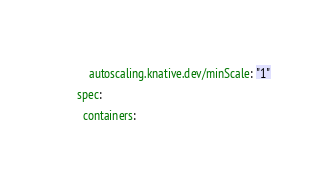<code> <loc_0><loc_0><loc_500><loc_500><_YAML_>        autoscaling.knative.dev/minScale: "1"
    spec:
      containers:</code> 